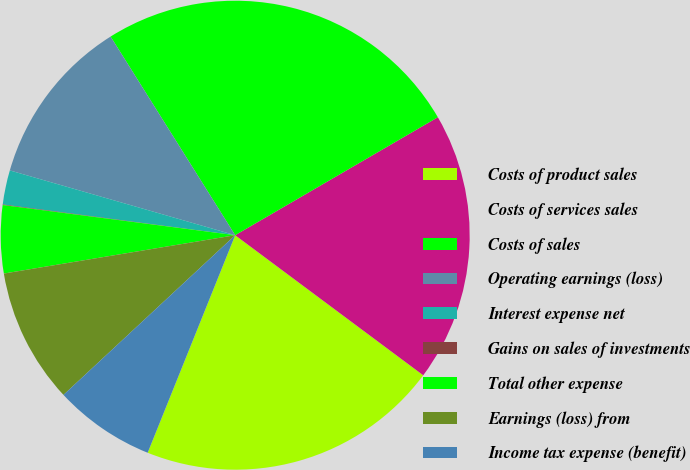<chart> <loc_0><loc_0><loc_500><loc_500><pie_chart><fcel>Costs of product sales<fcel>Costs of services sales<fcel>Costs of sales<fcel>Operating earnings (loss)<fcel>Interest expense net<fcel>Gains on sales of investments<fcel>Total other expense<fcel>Earnings (loss) from<fcel>Income tax expense (benefit)<nl><fcel>20.9%<fcel>18.58%<fcel>25.53%<fcel>11.63%<fcel>2.36%<fcel>0.04%<fcel>4.67%<fcel>9.31%<fcel>6.99%<nl></chart> 